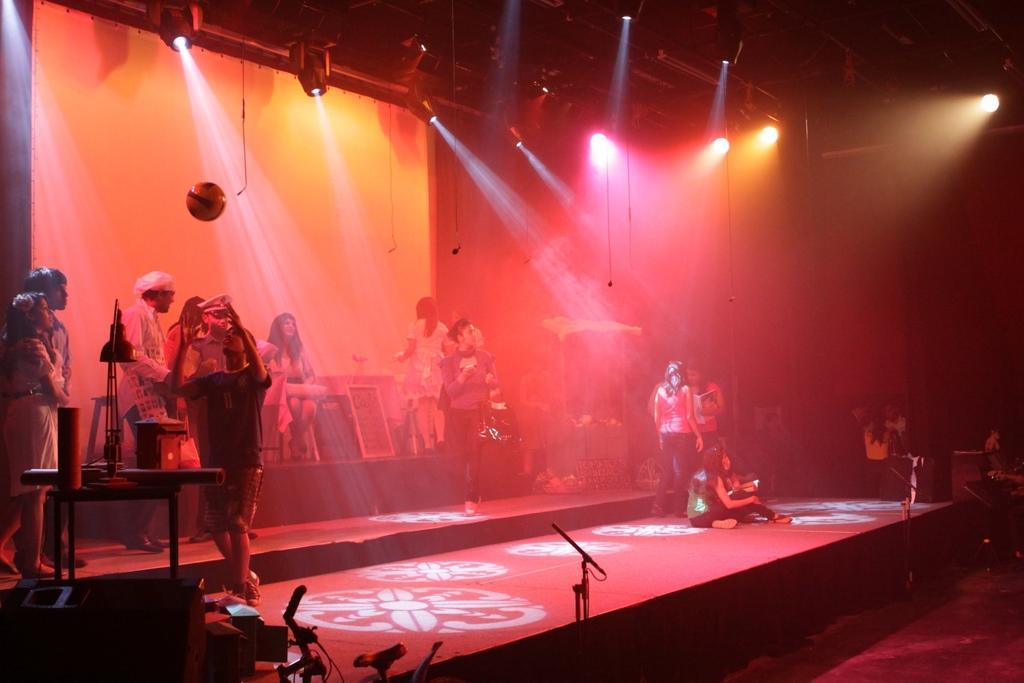Describe this image in one or two sentences. In this Image I can see the group of people are on the stage. To the left I can see some objects. In the top there are lights and the banner. 